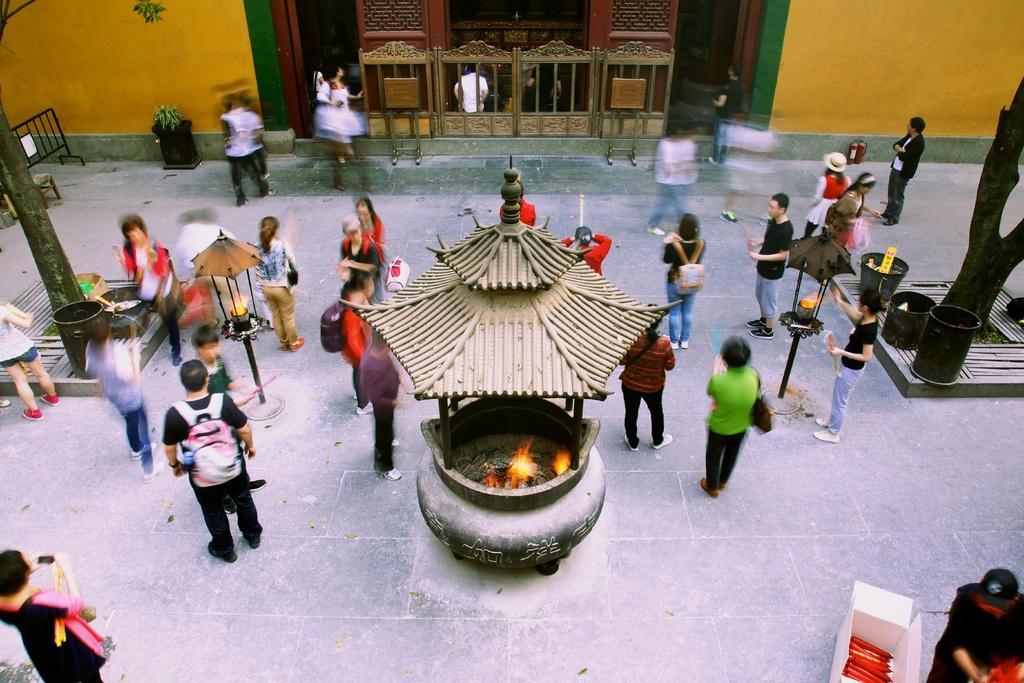Please provide a concise description of this image. In the center of the image we can see fireplaces. In the background of the image we can see some persons, trees, drums, bins, barricade, plant, wall. At the bottom of the image we can see floor and box. In the background of the image we can see blur image of a person. At the top of the image we can see fire extinguisher. 